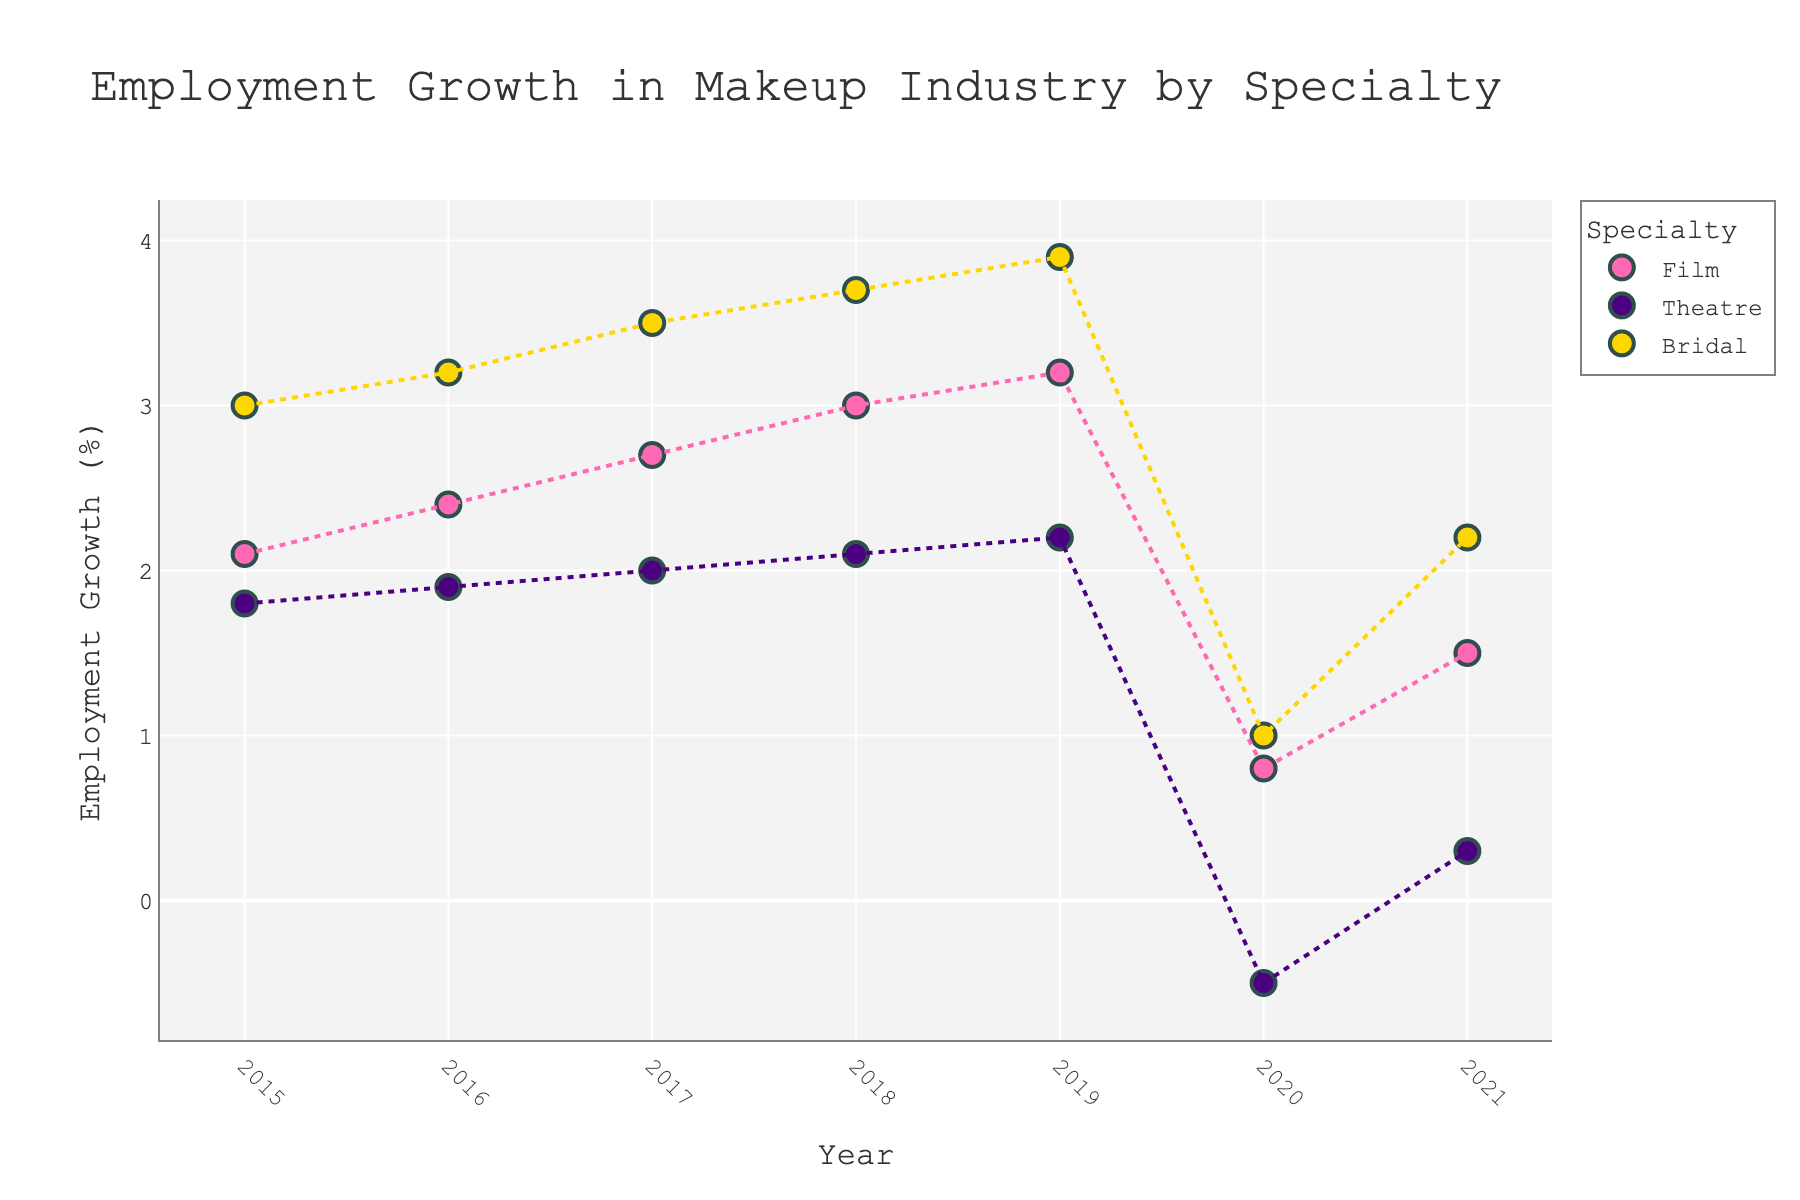How many specialties are shown in the plot? By observing the color legend, we can see three different specialties listed: Film, Theatre, and Bridal.
Answer: Three What does the color pink represent in the plot? The color pink corresponds to the employment growth data for the Film specialty, as indicated by the legend.
Answer: Film What is the title of the plot? The title of the plot is displayed at the top and reads "Employment Growth in Makeup Industry by Specialty."
Answer: Employment Growth in Makeup Industry by Specialty Which specialty experienced a negative employment growth in 2020? Analyzing the data points for 2020, we can see that Theatre has a data point below the zero line, indicating negative growth.
Answer: Theatre What was the employment growth for Bridal in 2019? Looking at the data points labeled for Bridal in 2019, the value is shown as 3.9%.
Answer: 3.9% Which specialty had the highest employment growth in 2017? Comparing the data points for 2017 across all specialties, Bridal shows the highest growth at 3.5%.
Answer: Bridal How did employment growth in Film change from 2019 to 2020? For Film, we see employment growth going from 3.2% in 2019 to 0.8% in 2020. To find the change, subtract 0.8 from 3.2, which gives a decrease of 2.4%.
Answer: Decreased by 2.4% What is the overall trend in employment growth for Theatre from 2015 to 2021? Visually following the data points for Theatre from 2015 to 2021 shows a general increase until 2019, a sharp decline in 2020, and a slight recovery in 2021. The trendline also supports this observation.
Answer: Increasing then decreasing Which year had the lowest employment growth for all specialties combined? By inspecting the lowest points across all specialties, 2020 stands out as the year with minimum growth values for all specialties (Film at 0.8%, Theatre at -0.5%, Bridal at 1.0%).
Answer: 2020 How does Bridal's employment growth in 2021 compare to its peak year? Bridal's employment growth in 2021 is 2.2%. Its peak value occurred in 2019 with 3.9%. Comparing these, 2.2% is less than 3.9%.
Answer: Less 